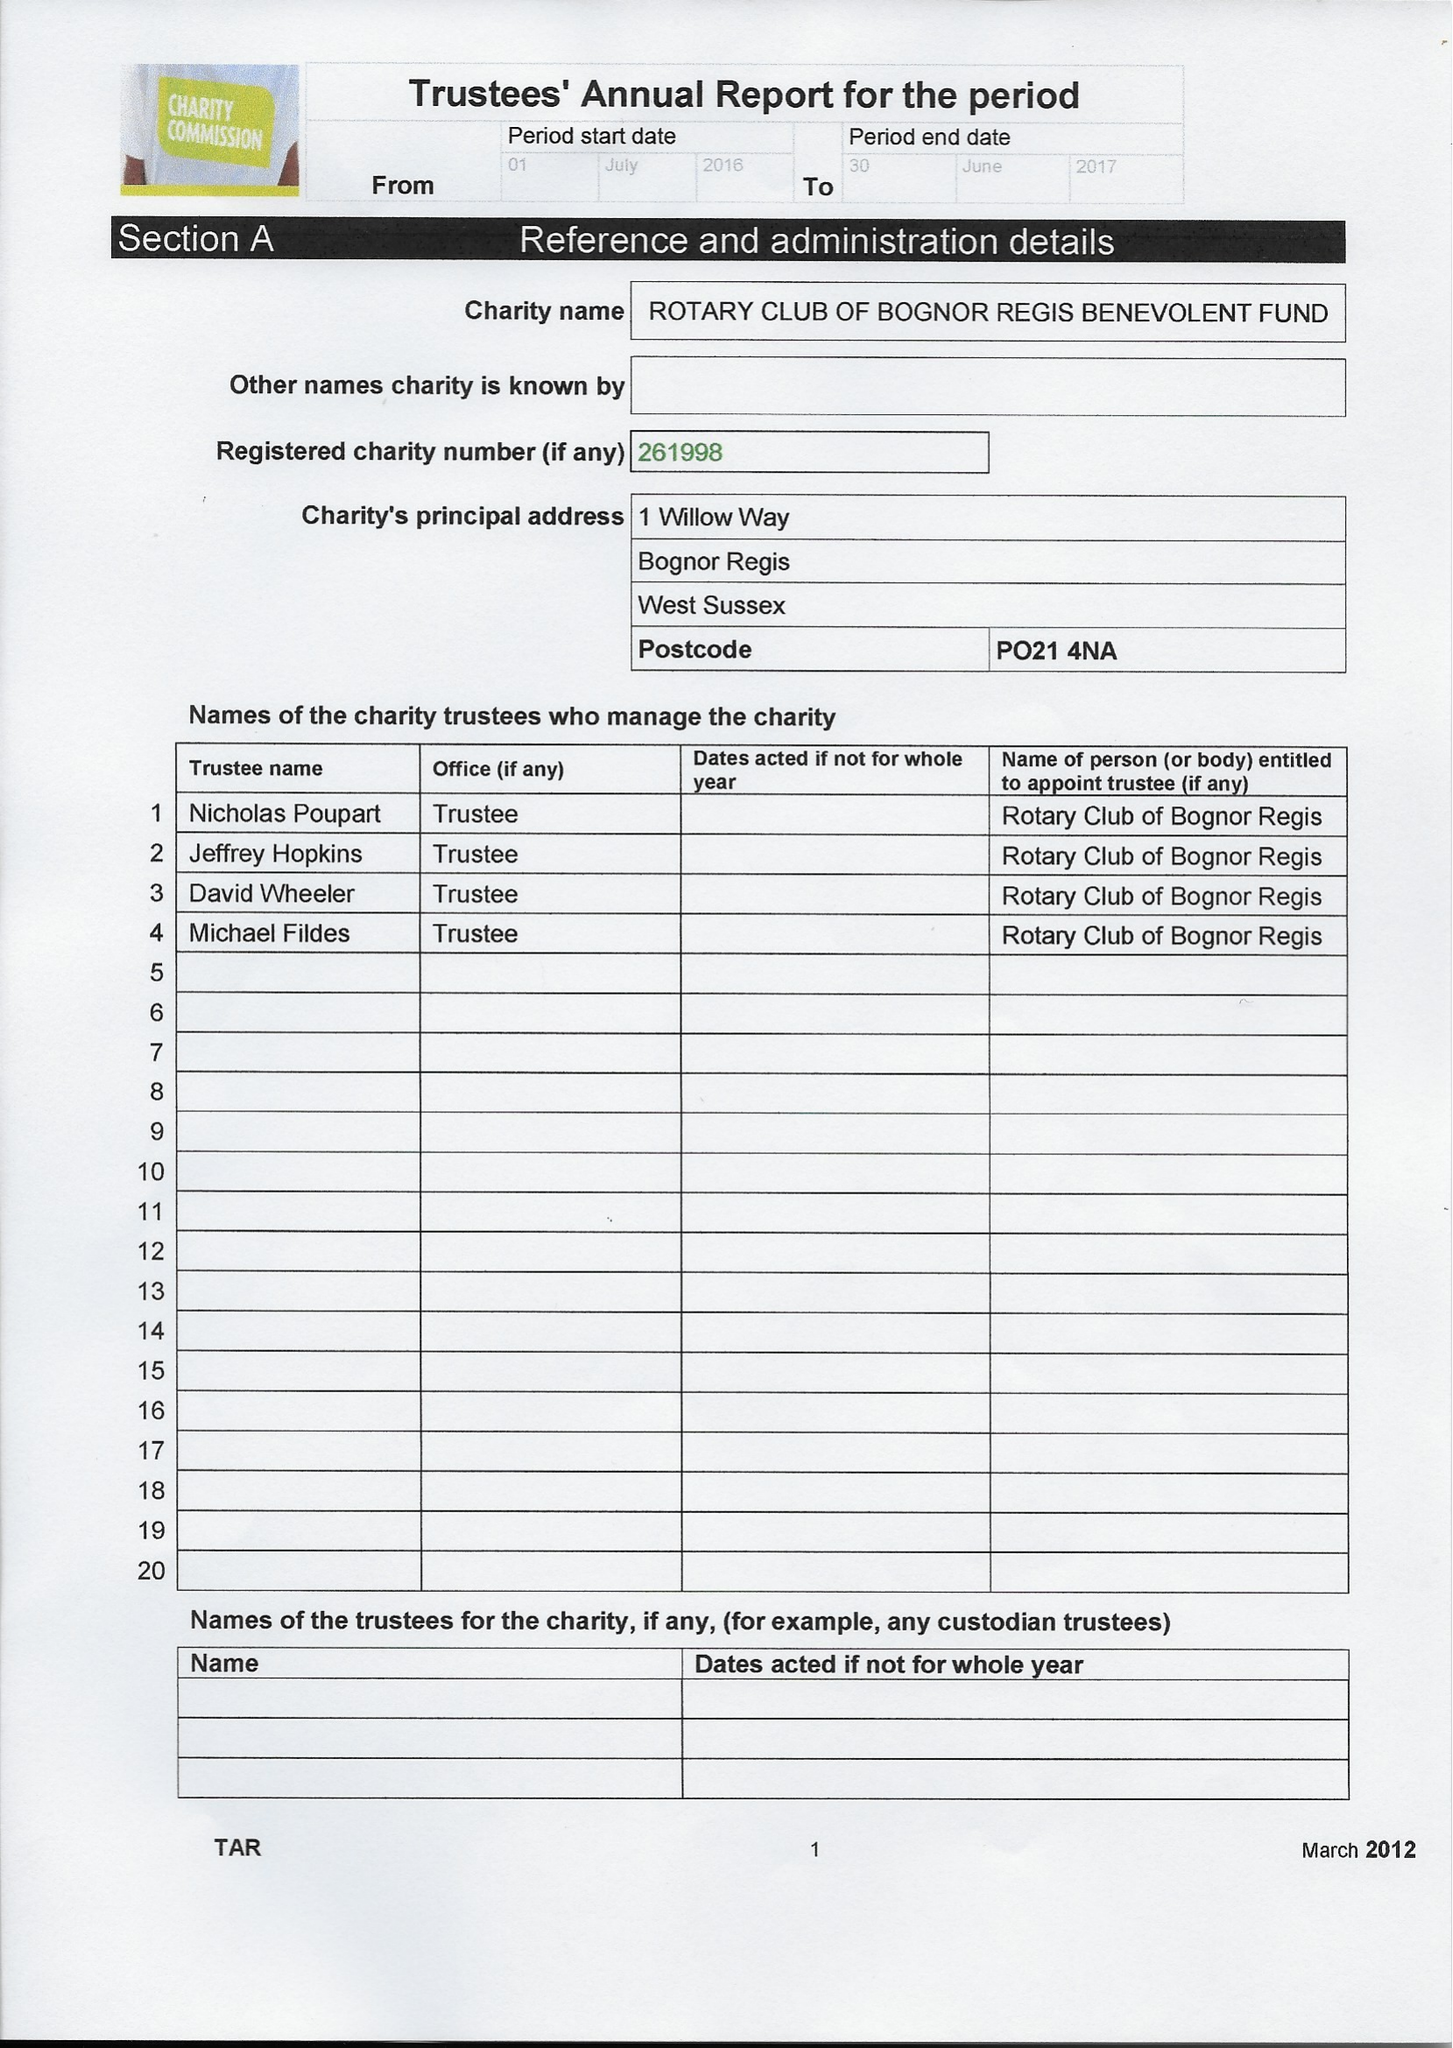What is the value for the report_date?
Answer the question using a single word or phrase. 2017-06-30 